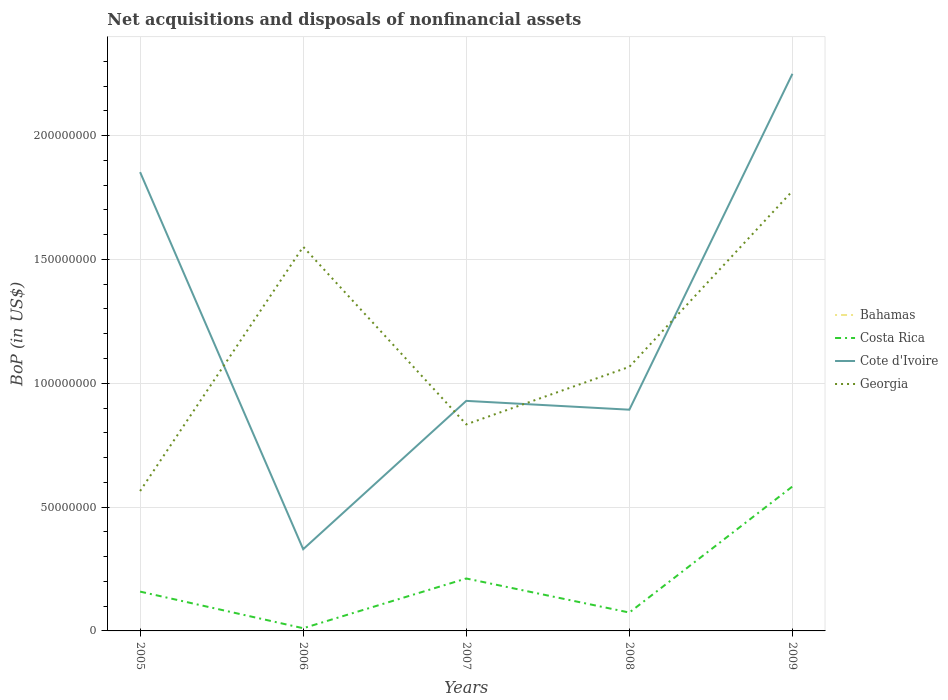Does the line corresponding to Bahamas intersect with the line corresponding to Cote d'Ivoire?
Keep it short and to the point. No. Is the number of lines equal to the number of legend labels?
Your answer should be very brief. No. Across all years, what is the maximum Balance of Payments in Costa Rica?
Your answer should be compact. 1.09e+06. What is the total Balance of Payments in Georgia in the graph?
Your response must be concise. -9.86e+07. What is the difference between the highest and the second highest Balance of Payments in Costa Rica?
Ensure brevity in your answer.  5.72e+07. What is the difference between the highest and the lowest Balance of Payments in Georgia?
Your answer should be compact. 2. Is the Balance of Payments in Bahamas strictly greater than the Balance of Payments in Cote d'Ivoire over the years?
Ensure brevity in your answer.  Yes. How many years are there in the graph?
Provide a short and direct response. 5. What is the difference between two consecutive major ticks on the Y-axis?
Offer a terse response. 5.00e+07. Are the values on the major ticks of Y-axis written in scientific E-notation?
Ensure brevity in your answer.  No. Does the graph contain grids?
Your response must be concise. Yes. Where does the legend appear in the graph?
Provide a succinct answer. Center right. How many legend labels are there?
Give a very brief answer. 4. What is the title of the graph?
Give a very brief answer. Net acquisitions and disposals of nonfinancial assets. What is the label or title of the Y-axis?
Ensure brevity in your answer.  BoP (in US$). What is the BoP (in US$) in Costa Rica in 2005?
Your response must be concise. 1.59e+07. What is the BoP (in US$) of Cote d'Ivoire in 2005?
Make the answer very short. 1.85e+08. What is the BoP (in US$) in Georgia in 2005?
Offer a very short reply. 5.65e+07. What is the BoP (in US$) of Bahamas in 2006?
Your answer should be compact. 0. What is the BoP (in US$) of Costa Rica in 2006?
Offer a terse response. 1.09e+06. What is the BoP (in US$) in Cote d'Ivoire in 2006?
Offer a terse response. 3.30e+07. What is the BoP (in US$) in Georgia in 2006?
Provide a short and direct response. 1.55e+08. What is the BoP (in US$) of Bahamas in 2007?
Ensure brevity in your answer.  0. What is the BoP (in US$) of Costa Rica in 2007?
Your answer should be compact. 2.12e+07. What is the BoP (in US$) in Cote d'Ivoire in 2007?
Your answer should be very brief. 9.29e+07. What is the BoP (in US$) of Georgia in 2007?
Keep it short and to the point. 8.34e+07. What is the BoP (in US$) in Bahamas in 2008?
Make the answer very short. 0. What is the BoP (in US$) of Costa Rica in 2008?
Give a very brief answer. 7.42e+06. What is the BoP (in US$) in Cote d'Ivoire in 2008?
Keep it short and to the point. 8.93e+07. What is the BoP (in US$) of Georgia in 2008?
Your response must be concise. 1.07e+08. What is the BoP (in US$) in Bahamas in 2009?
Provide a succinct answer. 0. What is the BoP (in US$) of Costa Rica in 2009?
Give a very brief answer. 5.83e+07. What is the BoP (in US$) in Cote d'Ivoire in 2009?
Your answer should be compact. 2.25e+08. What is the BoP (in US$) of Georgia in 2009?
Ensure brevity in your answer.  1.78e+08. Across all years, what is the maximum BoP (in US$) in Costa Rica?
Offer a terse response. 5.83e+07. Across all years, what is the maximum BoP (in US$) in Cote d'Ivoire?
Offer a terse response. 2.25e+08. Across all years, what is the maximum BoP (in US$) in Georgia?
Provide a succinct answer. 1.78e+08. Across all years, what is the minimum BoP (in US$) of Costa Rica?
Offer a very short reply. 1.09e+06. Across all years, what is the minimum BoP (in US$) of Cote d'Ivoire?
Provide a succinct answer. 3.30e+07. Across all years, what is the minimum BoP (in US$) in Georgia?
Provide a succinct answer. 5.65e+07. What is the total BoP (in US$) of Bahamas in the graph?
Give a very brief answer. 0. What is the total BoP (in US$) in Costa Rica in the graph?
Offer a very short reply. 1.04e+08. What is the total BoP (in US$) of Cote d'Ivoire in the graph?
Provide a succinct answer. 6.25e+08. What is the total BoP (in US$) in Georgia in the graph?
Your response must be concise. 5.79e+08. What is the difference between the BoP (in US$) of Costa Rica in 2005 and that in 2006?
Make the answer very short. 1.48e+07. What is the difference between the BoP (in US$) in Cote d'Ivoire in 2005 and that in 2006?
Your response must be concise. 1.52e+08. What is the difference between the BoP (in US$) in Georgia in 2005 and that in 2006?
Provide a short and direct response. -9.86e+07. What is the difference between the BoP (in US$) in Costa Rica in 2005 and that in 2007?
Your answer should be very brief. -5.29e+06. What is the difference between the BoP (in US$) in Cote d'Ivoire in 2005 and that in 2007?
Your answer should be compact. 9.24e+07. What is the difference between the BoP (in US$) of Georgia in 2005 and that in 2007?
Your answer should be compact. -2.69e+07. What is the difference between the BoP (in US$) in Costa Rica in 2005 and that in 2008?
Make the answer very short. 8.45e+06. What is the difference between the BoP (in US$) in Cote d'Ivoire in 2005 and that in 2008?
Your response must be concise. 9.59e+07. What is the difference between the BoP (in US$) of Georgia in 2005 and that in 2008?
Provide a short and direct response. -5.01e+07. What is the difference between the BoP (in US$) in Costa Rica in 2005 and that in 2009?
Provide a succinct answer. -4.24e+07. What is the difference between the BoP (in US$) in Cote d'Ivoire in 2005 and that in 2009?
Ensure brevity in your answer.  -3.97e+07. What is the difference between the BoP (in US$) of Georgia in 2005 and that in 2009?
Offer a very short reply. -1.21e+08. What is the difference between the BoP (in US$) in Costa Rica in 2006 and that in 2007?
Your answer should be very brief. -2.01e+07. What is the difference between the BoP (in US$) in Cote d'Ivoire in 2006 and that in 2007?
Make the answer very short. -5.99e+07. What is the difference between the BoP (in US$) in Georgia in 2006 and that in 2007?
Give a very brief answer. 7.17e+07. What is the difference between the BoP (in US$) in Costa Rica in 2006 and that in 2008?
Your answer should be very brief. -6.33e+06. What is the difference between the BoP (in US$) in Cote d'Ivoire in 2006 and that in 2008?
Ensure brevity in your answer.  -5.63e+07. What is the difference between the BoP (in US$) of Georgia in 2006 and that in 2008?
Your response must be concise. 4.85e+07. What is the difference between the BoP (in US$) in Costa Rica in 2006 and that in 2009?
Ensure brevity in your answer.  -5.72e+07. What is the difference between the BoP (in US$) of Cote d'Ivoire in 2006 and that in 2009?
Offer a terse response. -1.92e+08. What is the difference between the BoP (in US$) of Georgia in 2006 and that in 2009?
Your answer should be compact. -2.25e+07. What is the difference between the BoP (in US$) of Costa Rica in 2007 and that in 2008?
Your response must be concise. 1.37e+07. What is the difference between the BoP (in US$) in Cote d'Ivoire in 2007 and that in 2008?
Your response must be concise. 3.56e+06. What is the difference between the BoP (in US$) of Georgia in 2007 and that in 2008?
Your response must be concise. -2.32e+07. What is the difference between the BoP (in US$) in Costa Rica in 2007 and that in 2009?
Your answer should be very brief. -3.72e+07. What is the difference between the BoP (in US$) in Cote d'Ivoire in 2007 and that in 2009?
Ensure brevity in your answer.  -1.32e+08. What is the difference between the BoP (in US$) of Georgia in 2007 and that in 2009?
Your response must be concise. -9.42e+07. What is the difference between the BoP (in US$) in Costa Rica in 2008 and that in 2009?
Give a very brief answer. -5.09e+07. What is the difference between the BoP (in US$) of Cote d'Ivoire in 2008 and that in 2009?
Give a very brief answer. -1.36e+08. What is the difference between the BoP (in US$) in Georgia in 2008 and that in 2009?
Provide a succinct answer. -7.10e+07. What is the difference between the BoP (in US$) in Costa Rica in 2005 and the BoP (in US$) in Cote d'Ivoire in 2006?
Offer a very short reply. -1.71e+07. What is the difference between the BoP (in US$) of Costa Rica in 2005 and the BoP (in US$) of Georgia in 2006?
Your answer should be very brief. -1.39e+08. What is the difference between the BoP (in US$) of Cote d'Ivoire in 2005 and the BoP (in US$) of Georgia in 2006?
Offer a very short reply. 3.01e+07. What is the difference between the BoP (in US$) in Costa Rica in 2005 and the BoP (in US$) in Cote d'Ivoire in 2007?
Ensure brevity in your answer.  -7.70e+07. What is the difference between the BoP (in US$) of Costa Rica in 2005 and the BoP (in US$) of Georgia in 2007?
Provide a succinct answer. -6.75e+07. What is the difference between the BoP (in US$) of Cote d'Ivoire in 2005 and the BoP (in US$) of Georgia in 2007?
Your answer should be compact. 1.02e+08. What is the difference between the BoP (in US$) of Costa Rica in 2005 and the BoP (in US$) of Cote d'Ivoire in 2008?
Your response must be concise. -7.34e+07. What is the difference between the BoP (in US$) in Costa Rica in 2005 and the BoP (in US$) in Georgia in 2008?
Keep it short and to the point. -9.07e+07. What is the difference between the BoP (in US$) of Cote d'Ivoire in 2005 and the BoP (in US$) of Georgia in 2008?
Your answer should be compact. 7.86e+07. What is the difference between the BoP (in US$) of Costa Rica in 2005 and the BoP (in US$) of Cote d'Ivoire in 2009?
Provide a short and direct response. -2.09e+08. What is the difference between the BoP (in US$) of Costa Rica in 2005 and the BoP (in US$) of Georgia in 2009?
Ensure brevity in your answer.  -1.62e+08. What is the difference between the BoP (in US$) of Cote d'Ivoire in 2005 and the BoP (in US$) of Georgia in 2009?
Provide a succinct answer. 7.62e+06. What is the difference between the BoP (in US$) of Costa Rica in 2006 and the BoP (in US$) of Cote d'Ivoire in 2007?
Your answer should be compact. -9.18e+07. What is the difference between the BoP (in US$) of Costa Rica in 2006 and the BoP (in US$) of Georgia in 2007?
Your response must be concise. -8.23e+07. What is the difference between the BoP (in US$) of Cote d'Ivoire in 2006 and the BoP (in US$) of Georgia in 2007?
Offer a very short reply. -5.04e+07. What is the difference between the BoP (in US$) of Costa Rica in 2006 and the BoP (in US$) of Cote d'Ivoire in 2008?
Provide a short and direct response. -8.82e+07. What is the difference between the BoP (in US$) of Costa Rica in 2006 and the BoP (in US$) of Georgia in 2008?
Your answer should be very brief. -1.06e+08. What is the difference between the BoP (in US$) of Cote d'Ivoire in 2006 and the BoP (in US$) of Georgia in 2008?
Ensure brevity in your answer.  -7.36e+07. What is the difference between the BoP (in US$) of Costa Rica in 2006 and the BoP (in US$) of Cote d'Ivoire in 2009?
Offer a terse response. -2.24e+08. What is the difference between the BoP (in US$) in Costa Rica in 2006 and the BoP (in US$) in Georgia in 2009?
Offer a very short reply. -1.77e+08. What is the difference between the BoP (in US$) in Cote d'Ivoire in 2006 and the BoP (in US$) in Georgia in 2009?
Your response must be concise. -1.45e+08. What is the difference between the BoP (in US$) in Costa Rica in 2007 and the BoP (in US$) in Cote d'Ivoire in 2008?
Your answer should be compact. -6.81e+07. What is the difference between the BoP (in US$) of Costa Rica in 2007 and the BoP (in US$) of Georgia in 2008?
Provide a succinct answer. -8.55e+07. What is the difference between the BoP (in US$) in Cote d'Ivoire in 2007 and the BoP (in US$) in Georgia in 2008?
Your response must be concise. -1.37e+07. What is the difference between the BoP (in US$) of Costa Rica in 2007 and the BoP (in US$) of Cote d'Ivoire in 2009?
Make the answer very short. -2.04e+08. What is the difference between the BoP (in US$) of Costa Rica in 2007 and the BoP (in US$) of Georgia in 2009?
Your response must be concise. -1.56e+08. What is the difference between the BoP (in US$) of Cote d'Ivoire in 2007 and the BoP (in US$) of Georgia in 2009?
Make the answer very short. -8.47e+07. What is the difference between the BoP (in US$) in Costa Rica in 2008 and the BoP (in US$) in Cote d'Ivoire in 2009?
Give a very brief answer. -2.18e+08. What is the difference between the BoP (in US$) of Costa Rica in 2008 and the BoP (in US$) of Georgia in 2009?
Provide a succinct answer. -1.70e+08. What is the difference between the BoP (in US$) in Cote d'Ivoire in 2008 and the BoP (in US$) in Georgia in 2009?
Ensure brevity in your answer.  -8.83e+07. What is the average BoP (in US$) of Costa Rica per year?
Offer a terse response. 2.08e+07. What is the average BoP (in US$) of Cote d'Ivoire per year?
Make the answer very short. 1.25e+08. What is the average BoP (in US$) of Georgia per year?
Provide a short and direct response. 1.16e+08. In the year 2005, what is the difference between the BoP (in US$) of Costa Rica and BoP (in US$) of Cote d'Ivoire?
Provide a succinct answer. -1.69e+08. In the year 2005, what is the difference between the BoP (in US$) of Costa Rica and BoP (in US$) of Georgia?
Keep it short and to the point. -4.06e+07. In the year 2005, what is the difference between the BoP (in US$) in Cote d'Ivoire and BoP (in US$) in Georgia?
Provide a short and direct response. 1.29e+08. In the year 2006, what is the difference between the BoP (in US$) in Costa Rica and BoP (in US$) in Cote d'Ivoire?
Your answer should be very brief. -3.19e+07. In the year 2006, what is the difference between the BoP (in US$) of Costa Rica and BoP (in US$) of Georgia?
Your response must be concise. -1.54e+08. In the year 2006, what is the difference between the BoP (in US$) of Cote d'Ivoire and BoP (in US$) of Georgia?
Provide a succinct answer. -1.22e+08. In the year 2007, what is the difference between the BoP (in US$) in Costa Rica and BoP (in US$) in Cote d'Ivoire?
Keep it short and to the point. -7.17e+07. In the year 2007, what is the difference between the BoP (in US$) in Costa Rica and BoP (in US$) in Georgia?
Keep it short and to the point. -6.22e+07. In the year 2007, what is the difference between the BoP (in US$) of Cote d'Ivoire and BoP (in US$) of Georgia?
Offer a very short reply. 9.48e+06. In the year 2008, what is the difference between the BoP (in US$) in Costa Rica and BoP (in US$) in Cote d'Ivoire?
Your answer should be very brief. -8.19e+07. In the year 2008, what is the difference between the BoP (in US$) in Costa Rica and BoP (in US$) in Georgia?
Your answer should be very brief. -9.92e+07. In the year 2008, what is the difference between the BoP (in US$) in Cote d'Ivoire and BoP (in US$) in Georgia?
Your answer should be compact. -1.73e+07. In the year 2009, what is the difference between the BoP (in US$) of Costa Rica and BoP (in US$) of Cote d'Ivoire?
Make the answer very short. -1.67e+08. In the year 2009, what is the difference between the BoP (in US$) in Costa Rica and BoP (in US$) in Georgia?
Provide a succinct answer. -1.19e+08. In the year 2009, what is the difference between the BoP (in US$) of Cote d'Ivoire and BoP (in US$) of Georgia?
Offer a very short reply. 4.73e+07. What is the ratio of the BoP (in US$) of Costa Rica in 2005 to that in 2006?
Make the answer very short. 14.62. What is the ratio of the BoP (in US$) in Cote d'Ivoire in 2005 to that in 2006?
Ensure brevity in your answer.  5.62. What is the ratio of the BoP (in US$) of Georgia in 2005 to that in 2006?
Give a very brief answer. 0.36. What is the ratio of the BoP (in US$) of Costa Rica in 2005 to that in 2007?
Offer a terse response. 0.75. What is the ratio of the BoP (in US$) of Cote d'Ivoire in 2005 to that in 2007?
Your answer should be very brief. 1.99. What is the ratio of the BoP (in US$) of Georgia in 2005 to that in 2007?
Offer a terse response. 0.68. What is the ratio of the BoP (in US$) of Costa Rica in 2005 to that in 2008?
Offer a very short reply. 2.14. What is the ratio of the BoP (in US$) of Cote d'Ivoire in 2005 to that in 2008?
Your response must be concise. 2.07. What is the ratio of the BoP (in US$) in Georgia in 2005 to that in 2008?
Offer a very short reply. 0.53. What is the ratio of the BoP (in US$) of Costa Rica in 2005 to that in 2009?
Provide a succinct answer. 0.27. What is the ratio of the BoP (in US$) of Cote d'Ivoire in 2005 to that in 2009?
Make the answer very short. 0.82. What is the ratio of the BoP (in US$) in Georgia in 2005 to that in 2009?
Your answer should be compact. 0.32. What is the ratio of the BoP (in US$) of Costa Rica in 2006 to that in 2007?
Offer a very short reply. 0.05. What is the ratio of the BoP (in US$) in Cote d'Ivoire in 2006 to that in 2007?
Offer a very short reply. 0.36. What is the ratio of the BoP (in US$) in Georgia in 2006 to that in 2007?
Your response must be concise. 1.86. What is the ratio of the BoP (in US$) of Costa Rica in 2006 to that in 2008?
Your answer should be very brief. 0.15. What is the ratio of the BoP (in US$) of Cote d'Ivoire in 2006 to that in 2008?
Your response must be concise. 0.37. What is the ratio of the BoP (in US$) of Georgia in 2006 to that in 2008?
Ensure brevity in your answer.  1.45. What is the ratio of the BoP (in US$) in Costa Rica in 2006 to that in 2009?
Keep it short and to the point. 0.02. What is the ratio of the BoP (in US$) in Cote d'Ivoire in 2006 to that in 2009?
Provide a succinct answer. 0.15. What is the ratio of the BoP (in US$) in Georgia in 2006 to that in 2009?
Your answer should be very brief. 0.87. What is the ratio of the BoP (in US$) in Costa Rica in 2007 to that in 2008?
Give a very brief answer. 2.85. What is the ratio of the BoP (in US$) of Cote d'Ivoire in 2007 to that in 2008?
Offer a very short reply. 1.04. What is the ratio of the BoP (in US$) of Georgia in 2007 to that in 2008?
Make the answer very short. 0.78. What is the ratio of the BoP (in US$) of Costa Rica in 2007 to that in 2009?
Offer a very short reply. 0.36. What is the ratio of the BoP (in US$) in Cote d'Ivoire in 2007 to that in 2009?
Keep it short and to the point. 0.41. What is the ratio of the BoP (in US$) in Georgia in 2007 to that in 2009?
Give a very brief answer. 0.47. What is the ratio of the BoP (in US$) in Costa Rica in 2008 to that in 2009?
Your response must be concise. 0.13. What is the ratio of the BoP (in US$) of Cote d'Ivoire in 2008 to that in 2009?
Ensure brevity in your answer.  0.4. What is the ratio of the BoP (in US$) of Georgia in 2008 to that in 2009?
Offer a very short reply. 0.6. What is the difference between the highest and the second highest BoP (in US$) of Costa Rica?
Give a very brief answer. 3.72e+07. What is the difference between the highest and the second highest BoP (in US$) of Cote d'Ivoire?
Your answer should be compact. 3.97e+07. What is the difference between the highest and the second highest BoP (in US$) of Georgia?
Offer a terse response. 2.25e+07. What is the difference between the highest and the lowest BoP (in US$) of Costa Rica?
Your response must be concise. 5.72e+07. What is the difference between the highest and the lowest BoP (in US$) in Cote d'Ivoire?
Your answer should be compact. 1.92e+08. What is the difference between the highest and the lowest BoP (in US$) in Georgia?
Offer a terse response. 1.21e+08. 